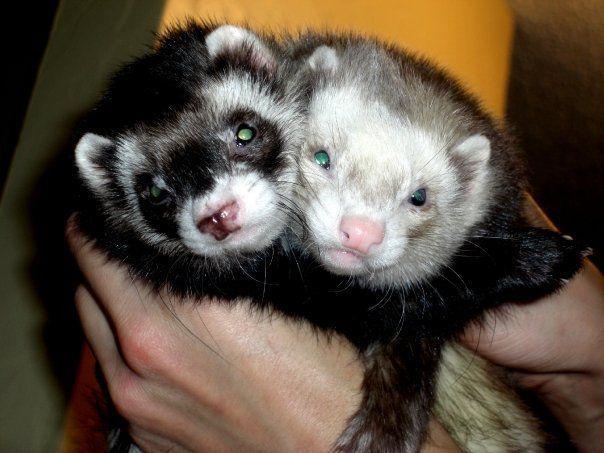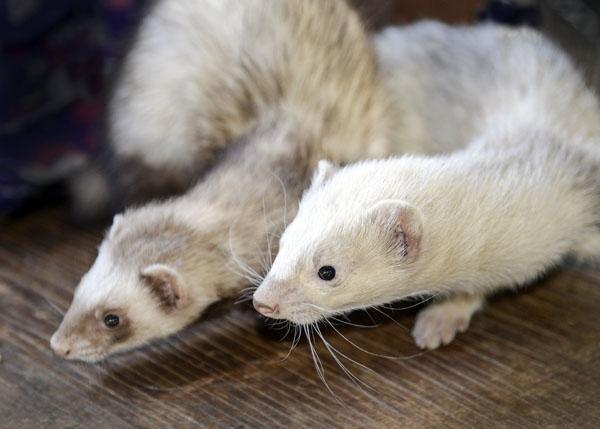The first image is the image on the left, the second image is the image on the right. For the images shown, is this caption "In one image, a little animal is facing forward with its mouth wide open and tongue showing, while a second image shows two similar animals in different colors." true? Answer yes or no. No. The first image is the image on the left, the second image is the image on the right. Assess this claim about the two images: "A pair of ferrets are held side-by-side in a pair of human hands.". Correct or not? Answer yes or no. Yes. 